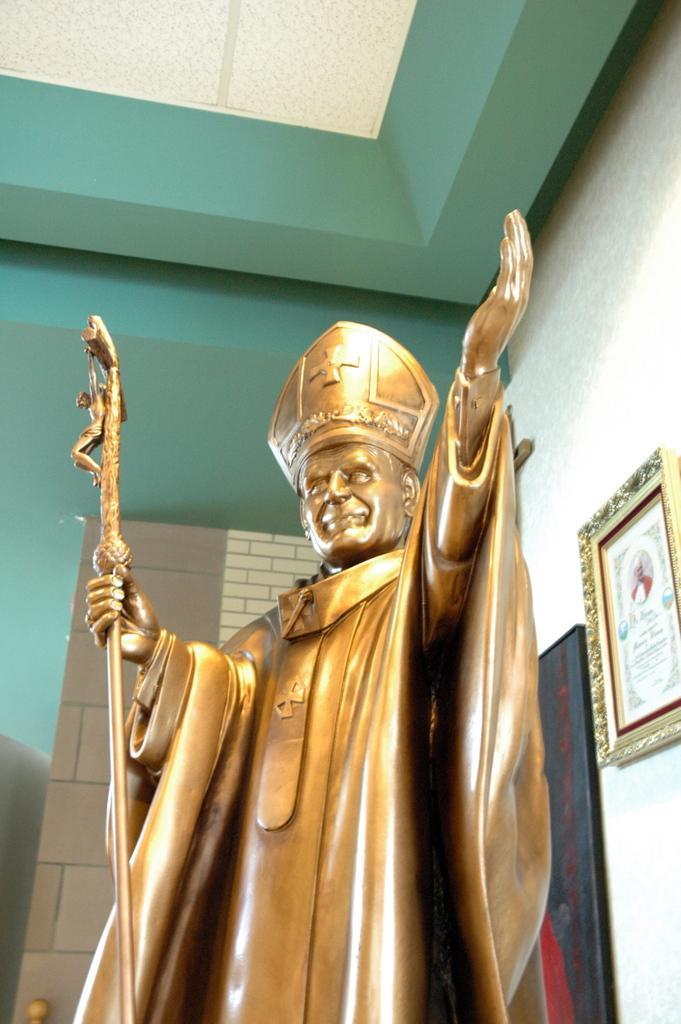Describe this image in one or two sentences. There is a statue of a person holding a stick in his hand and there is a photo frame attached to the wall in the right corner. 